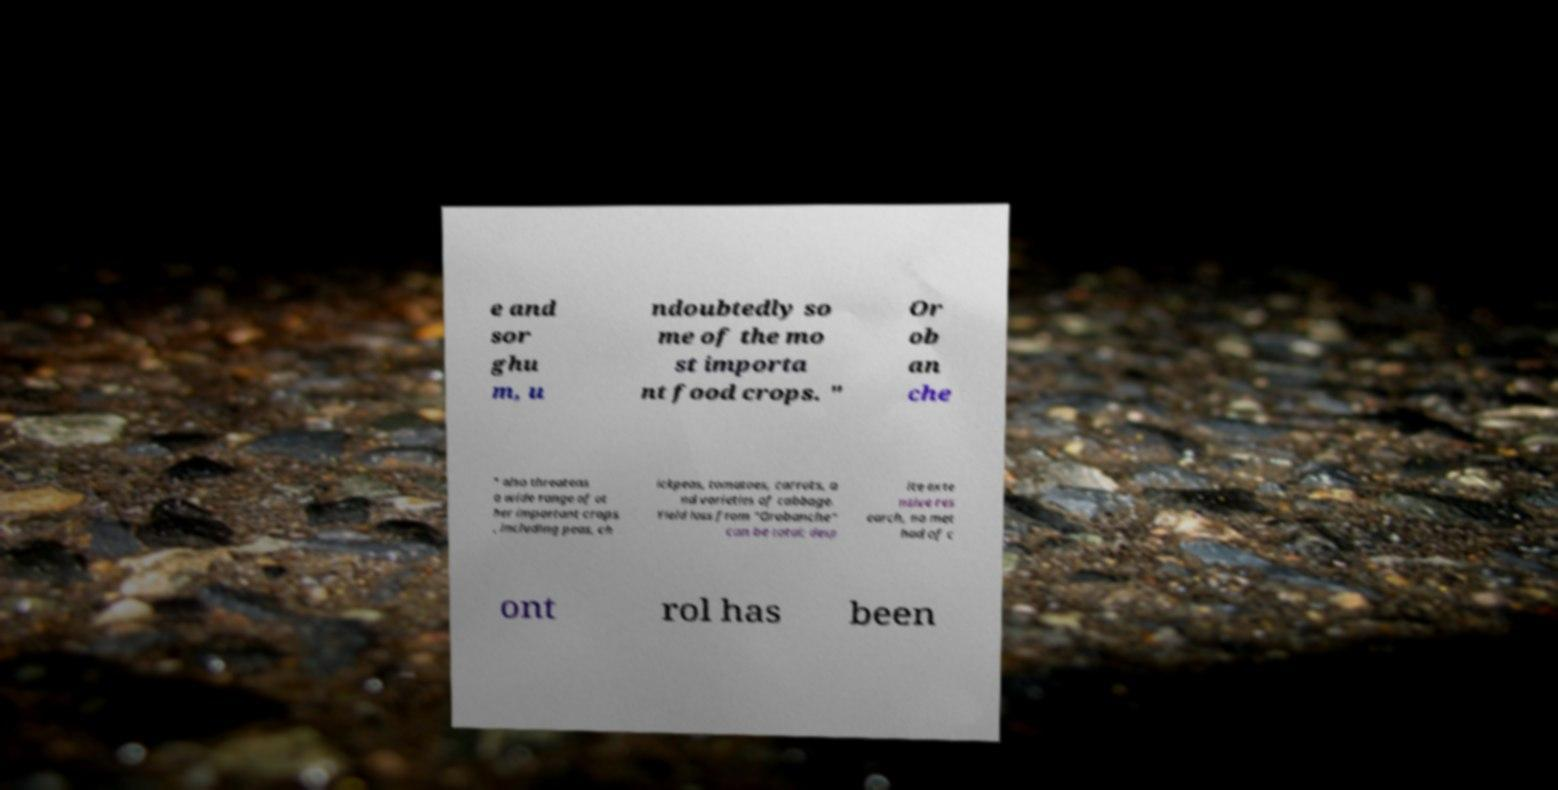I need the written content from this picture converted into text. Can you do that? e and sor ghu m, u ndoubtedly so me of the mo st importa nt food crops. " Or ob an che " also threatens a wide range of ot her important crops , including peas, ch ickpeas, tomatoes, carrots, a nd varieties of cabbage. Yield loss from "Orobanche" can be total; desp ite exte nsive res earch, no met hod of c ont rol has been 